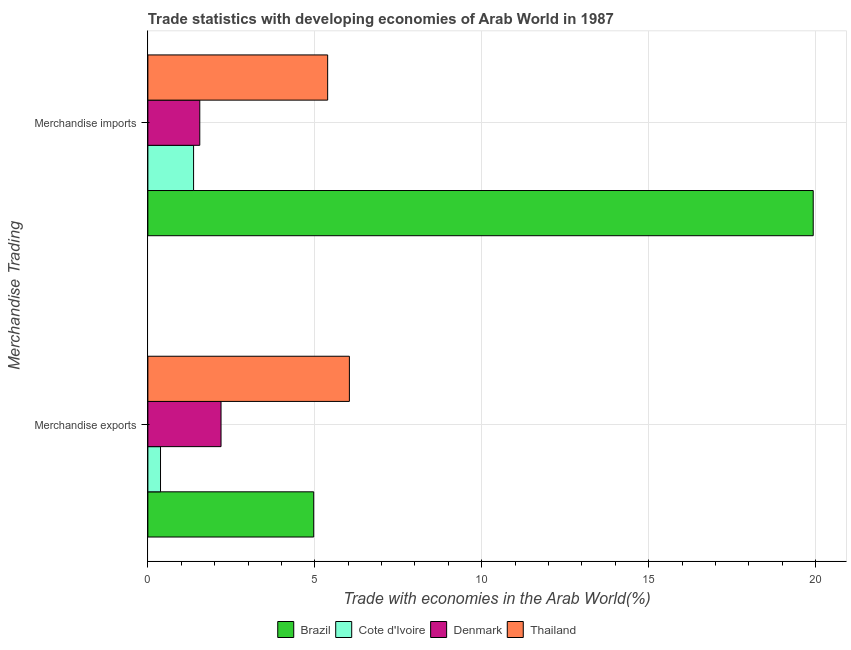How many bars are there on the 2nd tick from the bottom?
Your answer should be very brief. 4. What is the merchandise exports in Denmark?
Your response must be concise. 2.19. Across all countries, what is the maximum merchandise imports?
Your answer should be very brief. 19.93. Across all countries, what is the minimum merchandise exports?
Provide a succinct answer. 0.38. In which country was the merchandise exports minimum?
Your response must be concise. Cote d'Ivoire. What is the total merchandise imports in the graph?
Offer a very short reply. 28.24. What is the difference between the merchandise exports in Thailand and that in Brazil?
Offer a terse response. 1.07. What is the difference between the merchandise exports in Denmark and the merchandise imports in Cote d'Ivoire?
Provide a short and direct response. 0.82. What is the average merchandise exports per country?
Provide a succinct answer. 3.39. What is the difference between the merchandise exports and merchandise imports in Thailand?
Provide a short and direct response. 0.65. What is the ratio of the merchandise imports in Brazil to that in Thailand?
Keep it short and to the point. 3.7. In how many countries, is the merchandise imports greater than the average merchandise imports taken over all countries?
Give a very brief answer. 1. What does the 1st bar from the top in Merchandise exports represents?
Your answer should be very brief. Thailand. What does the 2nd bar from the bottom in Merchandise imports represents?
Keep it short and to the point. Cote d'Ivoire. How many countries are there in the graph?
Provide a short and direct response. 4. Does the graph contain any zero values?
Give a very brief answer. No. Where does the legend appear in the graph?
Make the answer very short. Bottom center. What is the title of the graph?
Provide a succinct answer. Trade statistics with developing economies of Arab World in 1987. Does "Latin America(developing only)" appear as one of the legend labels in the graph?
Your answer should be very brief. No. What is the label or title of the X-axis?
Your answer should be compact. Trade with economies in the Arab World(%). What is the label or title of the Y-axis?
Ensure brevity in your answer.  Merchandise Trading. What is the Trade with economies in the Arab World(%) in Brazil in Merchandise exports?
Give a very brief answer. 4.97. What is the Trade with economies in the Arab World(%) of Cote d'Ivoire in Merchandise exports?
Make the answer very short. 0.38. What is the Trade with economies in the Arab World(%) of Denmark in Merchandise exports?
Your answer should be compact. 2.19. What is the Trade with economies in the Arab World(%) of Thailand in Merchandise exports?
Keep it short and to the point. 6.04. What is the Trade with economies in the Arab World(%) in Brazil in Merchandise imports?
Your answer should be very brief. 19.93. What is the Trade with economies in the Arab World(%) of Cote d'Ivoire in Merchandise imports?
Keep it short and to the point. 1.37. What is the Trade with economies in the Arab World(%) of Denmark in Merchandise imports?
Provide a short and direct response. 1.56. What is the Trade with economies in the Arab World(%) in Thailand in Merchandise imports?
Make the answer very short. 5.39. Across all Merchandise Trading, what is the maximum Trade with economies in the Arab World(%) of Brazil?
Your answer should be compact. 19.93. Across all Merchandise Trading, what is the maximum Trade with economies in the Arab World(%) of Cote d'Ivoire?
Provide a succinct answer. 1.37. Across all Merchandise Trading, what is the maximum Trade with economies in the Arab World(%) in Denmark?
Your answer should be compact. 2.19. Across all Merchandise Trading, what is the maximum Trade with economies in the Arab World(%) of Thailand?
Offer a terse response. 6.04. Across all Merchandise Trading, what is the minimum Trade with economies in the Arab World(%) of Brazil?
Your answer should be compact. 4.97. Across all Merchandise Trading, what is the minimum Trade with economies in the Arab World(%) of Cote d'Ivoire?
Your response must be concise. 0.38. Across all Merchandise Trading, what is the minimum Trade with economies in the Arab World(%) in Denmark?
Provide a short and direct response. 1.56. Across all Merchandise Trading, what is the minimum Trade with economies in the Arab World(%) in Thailand?
Keep it short and to the point. 5.39. What is the total Trade with economies in the Arab World(%) in Brazil in the graph?
Your answer should be very brief. 24.9. What is the total Trade with economies in the Arab World(%) of Cote d'Ivoire in the graph?
Your answer should be compact. 1.75. What is the total Trade with economies in the Arab World(%) in Denmark in the graph?
Your answer should be compact. 3.75. What is the total Trade with economies in the Arab World(%) in Thailand in the graph?
Your response must be concise. 11.42. What is the difference between the Trade with economies in the Arab World(%) of Brazil in Merchandise exports and that in Merchandise imports?
Your answer should be very brief. -14.96. What is the difference between the Trade with economies in the Arab World(%) of Cote d'Ivoire in Merchandise exports and that in Merchandise imports?
Give a very brief answer. -0.99. What is the difference between the Trade with economies in the Arab World(%) in Denmark in Merchandise exports and that in Merchandise imports?
Make the answer very short. 0.64. What is the difference between the Trade with economies in the Arab World(%) in Thailand in Merchandise exports and that in Merchandise imports?
Provide a succinct answer. 0.65. What is the difference between the Trade with economies in the Arab World(%) in Brazil in Merchandise exports and the Trade with economies in the Arab World(%) in Cote d'Ivoire in Merchandise imports?
Give a very brief answer. 3.6. What is the difference between the Trade with economies in the Arab World(%) of Brazil in Merchandise exports and the Trade with economies in the Arab World(%) of Denmark in Merchandise imports?
Your answer should be very brief. 3.41. What is the difference between the Trade with economies in the Arab World(%) of Brazil in Merchandise exports and the Trade with economies in the Arab World(%) of Thailand in Merchandise imports?
Give a very brief answer. -0.42. What is the difference between the Trade with economies in the Arab World(%) of Cote d'Ivoire in Merchandise exports and the Trade with economies in the Arab World(%) of Denmark in Merchandise imports?
Your response must be concise. -1.18. What is the difference between the Trade with economies in the Arab World(%) of Cote d'Ivoire in Merchandise exports and the Trade with economies in the Arab World(%) of Thailand in Merchandise imports?
Your response must be concise. -5.01. What is the difference between the Trade with economies in the Arab World(%) in Denmark in Merchandise exports and the Trade with economies in the Arab World(%) in Thailand in Merchandise imports?
Make the answer very short. -3.19. What is the average Trade with economies in the Arab World(%) in Brazil per Merchandise Trading?
Provide a short and direct response. 12.45. What is the average Trade with economies in the Arab World(%) in Cote d'Ivoire per Merchandise Trading?
Your answer should be very brief. 0.87. What is the average Trade with economies in the Arab World(%) in Denmark per Merchandise Trading?
Provide a succinct answer. 1.87. What is the average Trade with economies in the Arab World(%) in Thailand per Merchandise Trading?
Provide a short and direct response. 5.71. What is the difference between the Trade with economies in the Arab World(%) in Brazil and Trade with economies in the Arab World(%) in Cote d'Ivoire in Merchandise exports?
Offer a terse response. 4.59. What is the difference between the Trade with economies in the Arab World(%) of Brazil and Trade with economies in the Arab World(%) of Denmark in Merchandise exports?
Ensure brevity in your answer.  2.78. What is the difference between the Trade with economies in the Arab World(%) in Brazil and Trade with economies in the Arab World(%) in Thailand in Merchandise exports?
Ensure brevity in your answer.  -1.07. What is the difference between the Trade with economies in the Arab World(%) in Cote d'Ivoire and Trade with economies in the Arab World(%) in Denmark in Merchandise exports?
Your answer should be compact. -1.81. What is the difference between the Trade with economies in the Arab World(%) of Cote d'Ivoire and Trade with economies in the Arab World(%) of Thailand in Merchandise exports?
Give a very brief answer. -5.66. What is the difference between the Trade with economies in the Arab World(%) in Denmark and Trade with economies in the Arab World(%) in Thailand in Merchandise exports?
Offer a terse response. -3.85. What is the difference between the Trade with economies in the Arab World(%) in Brazil and Trade with economies in the Arab World(%) in Cote d'Ivoire in Merchandise imports?
Provide a short and direct response. 18.56. What is the difference between the Trade with economies in the Arab World(%) of Brazil and Trade with economies in the Arab World(%) of Denmark in Merchandise imports?
Your answer should be very brief. 18.37. What is the difference between the Trade with economies in the Arab World(%) of Brazil and Trade with economies in the Arab World(%) of Thailand in Merchandise imports?
Your response must be concise. 14.54. What is the difference between the Trade with economies in the Arab World(%) in Cote d'Ivoire and Trade with economies in the Arab World(%) in Denmark in Merchandise imports?
Keep it short and to the point. -0.19. What is the difference between the Trade with economies in the Arab World(%) of Cote d'Ivoire and Trade with economies in the Arab World(%) of Thailand in Merchandise imports?
Ensure brevity in your answer.  -4.02. What is the difference between the Trade with economies in the Arab World(%) in Denmark and Trade with economies in the Arab World(%) in Thailand in Merchandise imports?
Your response must be concise. -3.83. What is the ratio of the Trade with economies in the Arab World(%) of Brazil in Merchandise exports to that in Merchandise imports?
Provide a short and direct response. 0.25. What is the ratio of the Trade with economies in the Arab World(%) of Cote d'Ivoire in Merchandise exports to that in Merchandise imports?
Provide a succinct answer. 0.28. What is the ratio of the Trade with economies in the Arab World(%) in Denmark in Merchandise exports to that in Merchandise imports?
Provide a short and direct response. 1.41. What is the ratio of the Trade with economies in the Arab World(%) of Thailand in Merchandise exports to that in Merchandise imports?
Your answer should be very brief. 1.12. What is the difference between the highest and the second highest Trade with economies in the Arab World(%) in Brazil?
Your answer should be compact. 14.96. What is the difference between the highest and the second highest Trade with economies in the Arab World(%) in Cote d'Ivoire?
Your response must be concise. 0.99. What is the difference between the highest and the second highest Trade with economies in the Arab World(%) in Denmark?
Provide a short and direct response. 0.64. What is the difference between the highest and the second highest Trade with economies in the Arab World(%) in Thailand?
Provide a short and direct response. 0.65. What is the difference between the highest and the lowest Trade with economies in the Arab World(%) of Brazil?
Give a very brief answer. 14.96. What is the difference between the highest and the lowest Trade with economies in the Arab World(%) in Cote d'Ivoire?
Offer a terse response. 0.99. What is the difference between the highest and the lowest Trade with economies in the Arab World(%) of Denmark?
Offer a very short reply. 0.64. What is the difference between the highest and the lowest Trade with economies in the Arab World(%) in Thailand?
Provide a short and direct response. 0.65. 